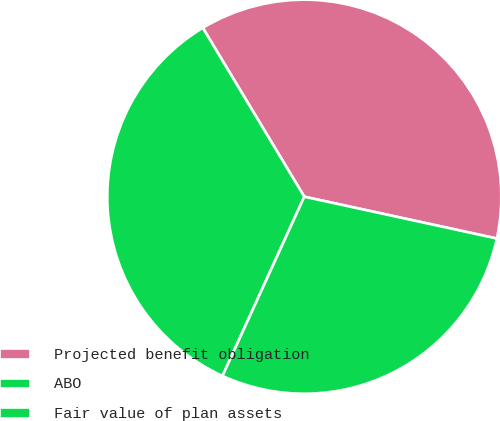Convert chart to OTSL. <chart><loc_0><loc_0><loc_500><loc_500><pie_chart><fcel>Projected benefit obligation<fcel>ABO<fcel>Fair value of plan assets<nl><fcel>37.02%<fcel>34.57%<fcel>28.41%<nl></chart> 